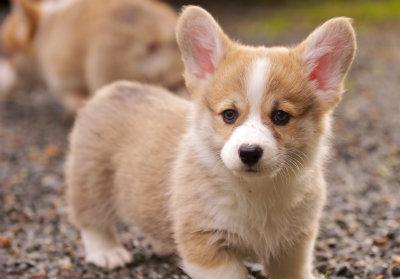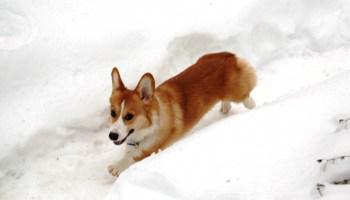The first image is the image on the left, the second image is the image on the right. Assess this claim about the two images: "An image shows a pair of short-legged dogs standing facing forward and posed side-by-side.". Correct or not? Answer yes or no. No. 